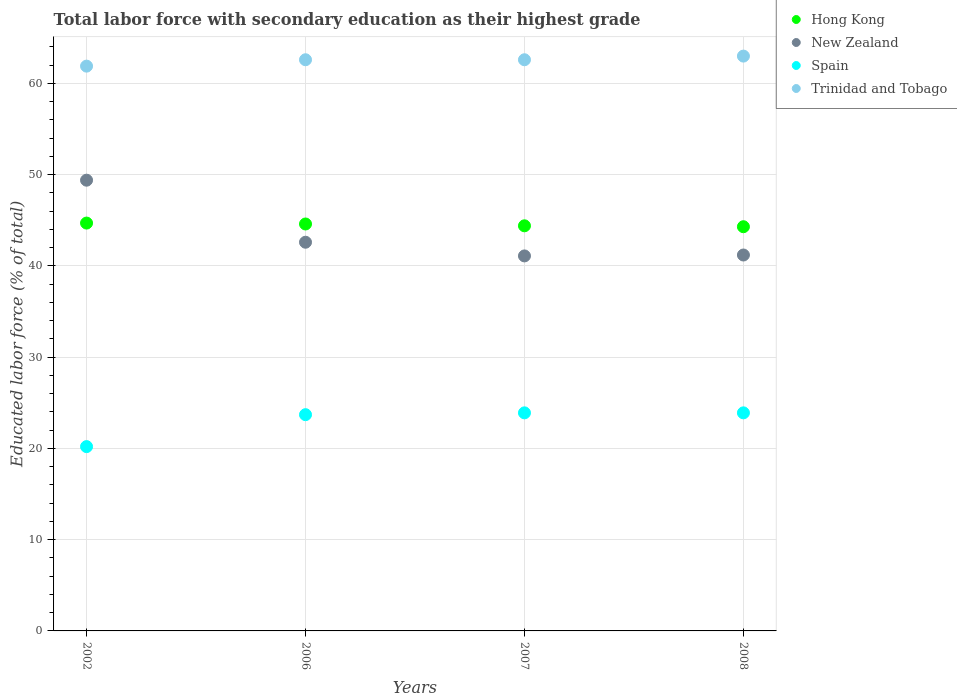How many different coloured dotlines are there?
Provide a short and direct response. 4. Is the number of dotlines equal to the number of legend labels?
Ensure brevity in your answer.  Yes. What is the percentage of total labor force with primary education in Hong Kong in 2007?
Your response must be concise. 44.4. Across all years, what is the maximum percentage of total labor force with primary education in New Zealand?
Offer a very short reply. 49.4. Across all years, what is the minimum percentage of total labor force with primary education in Spain?
Give a very brief answer. 20.2. What is the total percentage of total labor force with primary education in Hong Kong in the graph?
Keep it short and to the point. 178. What is the difference between the percentage of total labor force with primary education in Trinidad and Tobago in 2002 and that in 2008?
Give a very brief answer. -1.1. What is the difference between the percentage of total labor force with primary education in Trinidad and Tobago in 2006 and the percentage of total labor force with primary education in Hong Kong in 2002?
Your answer should be very brief. 17.9. What is the average percentage of total labor force with primary education in Trinidad and Tobago per year?
Your answer should be very brief. 62.52. In the year 2007, what is the difference between the percentage of total labor force with primary education in Hong Kong and percentage of total labor force with primary education in New Zealand?
Your response must be concise. 3.3. In how many years, is the percentage of total labor force with primary education in Hong Kong greater than 40 %?
Make the answer very short. 4. What is the ratio of the percentage of total labor force with primary education in Hong Kong in 2002 to that in 2008?
Your response must be concise. 1.01. What is the difference between the highest and the second highest percentage of total labor force with primary education in New Zealand?
Offer a very short reply. 6.8. What is the difference between the highest and the lowest percentage of total labor force with primary education in Trinidad and Tobago?
Your answer should be compact. 1.1. In how many years, is the percentage of total labor force with primary education in Trinidad and Tobago greater than the average percentage of total labor force with primary education in Trinidad and Tobago taken over all years?
Provide a succinct answer. 3. Is the sum of the percentage of total labor force with primary education in New Zealand in 2006 and 2007 greater than the maximum percentage of total labor force with primary education in Spain across all years?
Provide a short and direct response. Yes. Is it the case that in every year, the sum of the percentage of total labor force with primary education in Hong Kong and percentage of total labor force with primary education in Trinidad and Tobago  is greater than the percentage of total labor force with primary education in Spain?
Provide a short and direct response. Yes. Is the percentage of total labor force with primary education in New Zealand strictly less than the percentage of total labor force with primary education in Trinidad and Tobago over the years?
Your answer should be very brief. Yes. How many years are there in the graph?
Your answer should be compact. 4. What is the difference between two consecutive major ticks on the Y-axis?
Keep it short and to the point. 10. Are the values on the major ticks of Y-axis written in scientific E-notation?
Your answer should be compact. No. How are the legend labels stacked?
Offer a terse response. Vertical. What is the title of the graph?
Make the answer very short. Total labor force with secondary education as their highest grade. What is the label or title of the X-axis?
Your answer should be compact. Years. What is the label or title of the Y-axis?
Provide a short and direct response. Educated labor force (% of total). What is the Educated labor force (% of total) in Hong Kong in 2002?
Provide a short and direct response. 44.7. What is the Educated labor force (% of total) of New Zealand in 2002?
Ensure brevity in your answer.  49.4. What is the Educated labor force (% of total) of Spain in 2002?
Your answer should be compact. 20.2. What is the Educated labor force (% of total) in Trinidad and Tobago in 2002?
Provide a succinct answer. 61.9. What is the Educated labor force (% of total) of Hong Kong in 2006?
Offer a terse response. 44.6. What is the Educated labor force (% of total) in New Zealand in 2006?
Keep it short and to the point. 42.6. What is the Educated labor force (% of total) in Spain in 2006?
Give a very brief answer. 23.7. What is the Educated labor force (% of total) in Trinidad and Tobago in 2006?
Offer a terse response. 62.6. What is the Educated labor force (% of total) in Hong Kong in 2007?
Give a very brief answer. 44.4. What is the Educated labor force (% of total) of New Zealand in 2007?
Ensure brevity in your answer.  41.1. What is the Educated labor force (% of total) in Spain in 2007?
Provide a succinct answer. 23.9. What is the Educated labor force (% of total) in Trinidad and Tobago in 2007?
Offer a very short reply. 62.6. What is the Educated labor force (% of total) in Hong Kong in 2008?
Your answer should be very brief. 44.3. What is the Educated labor force (% of total) in New Zealand in 2008?
Provide a short and direct response. 41.2. What is the Educated labor force (% of total) of Spain in 2008?
Provide a short and direct response. 23.9. Across all years, what is the maximum Educated labor force (% of total) in Hong Kong?
Your answer should be very brief. 44.7. Across all years, what is the maximum Educated labor force (% of total) of New Zealand?
Provide a short and direct response. 49.4. Across all years, what is the maximum Educated labor force (% of total) in Spain?
Keep it short and to the point. 23.9. Across all years, what is the maximum Educated labor force (% of total) of Trinidad and Tobago?
Keep it short and to the point. 63. Across all years, what is the minimum Educated labor force (% of total) in Hong Kong?
Offer a very short reply. 44.3. Across all years, what is the minimum Educated labor force (% of total) in New Zealand?
Provide a succinct answer. 41.1. Across all years, what is the minimum Educated labor force (% of total) in Spain?
Your response must be concise. 20.2. Across all years, what is the minimum Educated labor force (% of total) of Trinidad and Tobago?
Offer a very short reply. 61.9. What is the total Educated labor force (% of total) of Hong Kong in the graph?
Make the answer very short. 178. What is the total Educated labor force (% of total) in New Zealand in the graph?
Give a very brief answer. 174.3. What is the total Educated labor force (% of total) of Spain in the graph?
Ensure brevity in your answer.  91.7. What is the total Educated labor force (% of total) in Trinidad and Tobago in the graph?
Make the answer very short. 250.1. What is the difference between the Educated labor force (% of total) in Hong Kong in 2002 and that in 2006?
Ensure brevity in your answer.  0.1. What is the difference between the Educated labor force (% of total) of New Zealand in 2002 and that in 2006?
Keep it short and to the point. 6.8. What is the difference between the Educated labor force (% of total) of Trinidad and Tobago in 2002 and that in 2006?
Your response must be concise. -0.7. What is the difference between the Educated labor force (% of total) of Trinidad and Tobago in 2002 and that in 2008?
Make the answer very short. -1.1. What is the difference between the Educated labor force (% of total) of New Zealand in 2006 and that in 2007?
Your response must be concise. 1.5. What is the difference between the Educated labor force (% of total) of Spain in 2006 and that in 2007?
Give a very brief answer. -0.2. What is the difference between the Educated labor force (% of total) in Spain in 2006 and that in 2008?
Provide a short and direct response. -0.2. What is the difference between the Educated labor force (% of total) of Hong Kong in 2007 and that in 2008?
Ensure brevity in your answer.  0.1. What is the difference between the Educated labor force (% of total) of Spain in 2007 and that in 2008?
Offer a very short reply. 0. What is the difference between the Educated labor force (% of total) in Hong Kong in 2002 and the Educated labor force (% of total) in New Zealand in 2006?
Offer a very short reply. 2.1. What is the difference between the Educated labor force (% of total) of Hong Kong in 2002 and the Educated labor force (% of total) of Spain in 2006?
Offer a terse response. 21. What is the difference between the Educated labor force (% of total) in Hong Kong in 2002 and the Educated labor force (% of total) in Trinidad and Tobago in 2006?
Keep it short and to the point. -17.9. What is the difference between the Educated labor force (% of total) in New Zealand in 2002 and the Educated labor force (% of total) in Spain in 2006?
Your answer should be compact. 25.7. What is the difference between the Educated labor force (% of total) in New Zealand in 2002 and the Educated labor force (% of total) in Trinidad and Tobago in 2006?
Make the answer very short. -13.2. What is the difference between the Educated labor force (% of total) of Spain in 2002 and the Educated labor force (% of total) of Trinidad and Tobago in 2006?
Your answer should be very brief. -42.4. What is the difference between the Educated labor force (% of total) in Hong Kong in 2002 and the Educated labor force (% of total) in New Zealand in 2007?
Offer a very short reply. 3.6. What is the difference between the Educated labor force (% of total) in Hong Kong in 2002 and the Educated labor force (% of total) in Spain in 2007?
Ensure brevity in your answer.  20.8. What is the difference between the Educated labor force (% of total) in Hong Kong in 2002 and the Educated labor force (% of total) in Trinidad and Tobago in 2007?
Your answer should be compact. -17.9. What is the difference between the Educated labor force (% of total) of Spain in 2002 and the Educated labor force (% of total) of Trinidad and Tobago in 2007?
Keep it short and to the point. -42.4. What is the difference between the Educated labor force (% of total) in Hong Kong in 2002 and the Educated labor force (% of total) in New Zealand in 2008?
Ensure brevity in your answer.  3.5. What is the difference between the Educated labor force (% of total) of Hong Kong in 2002 and the Educated labor force (% of total) of Spain in 2008?
Give a very brief answer. 20.8. What is the difference between the Educated labor force (% of total) of Hong Kong in 2002 and the Educated labor force (% of total) of Trinidad and Tobago in 2008?
Your response must be concise. -18.3. What is the difference between the Educated labor force (% of total) in New Zealand in 2002 and the Educated labor force (% of total) in Spain in 2008?
Your response must be concise. 25.5. What is the difference between the Educated labor force (% of total) in Spain in 2002 and the Educated labor force (% of total) in Trinidad and Tobago in 2008?
Provide a succinct answer. -42.8. What is the difference between the Educated labor force (% of total) of Hong Kong in 2006 and the Educated labor force (% of total) of New Zealand in 2007?
Offer a very short reply. 3.5. What is the difference between the Educated labor force (% of total) in Hong Kong in 2006 and the Educated labor force (% of total) in Spain in 2007?
Give a very brief answer. 20.7. What is the difference between the Educated labor force (% of total) in Hong Kong in 2006 and the Educated labor force (% of total) in Trinidad and Tobago in 2007?
Provide a succinct answer. -18. What is the difference between the Educated labor force (% of total) in New Zealand in 2006 and the Educated labor force (% of total) in Trinidad and Tobago in 2007?
Your response must be concise. -20. What is the difference between the Educated labor force (% of total) in Spain in 2006 and the Educated labor force (% of total) in Trinidad and Tobago in 2007?
Provide a short and direct response. -38.9. What is the difference between the Educated labor force (% of total) of Hong Kong in 2006 and the Educated labor force (% of total) of New Zealand in 2008?
Offer a very short reply. 3.4. What is the difference between the Educated labor force (% of total) in Hong Kong in 2006 and the Educated labor force (% of total) in Spain in 2008?
Offer a very short reply. 20.7. What is the difference between the Educated labor force (% of total) in Hong Kong in 2006 and the Educated labor force (% of total) in Trinidad and Tobago in 2008?
Your answer should be compact. -18.4. What is the difference between the Educated labor force (% of total) in New Zealand in 2006 and the Educated labor force (% of total) in Trinidad and Tobago in 2008?
Ensure brevity in your answer.  -20.4. What is the difference between the Educated labor force (% of total) in Spain in 2006 and the Educated labor force (% of total) in Trinidad and Tobago in 2008?
Ensure brevity in your answer.  -39.3. What is the difference between the Educated labor force (% of total) in Hong Kong in 2007 and the Educated labor force (% of total) in New Zealand in 2008?
Your answer should be compact. 3.2. What is the difference between the Educated labor force (% of total) in Hong Kong in 2007 and the Educated labor force (% of total) in Spain in 2008?
Ensure brevity in your answer.  20.5. What is the difference between the Educated labor force (% of total) of Hong Kong in 2007 and the Educated labor force (% of total) of Trinidad and Tobago in 2008?
Ensure brevity in your answer.  -18.6. What is the difference between the Educated labor force (% of total) of New Zealand in 2007 and the Educated labor force (% of total) of Spain in 2008?
Provide a short and direct response. 17.2. What is the difference between the Educated labor force (% of total) of New Zealand in 2007 and the Educated labor force (% of total) of Trinidad and Tobago in 2008?
Give a very brief answer. -21.9. What is the difference between the Educated labor force (% of total) in Spain in 2007 and the Educated labor force (% of total) in Trinidad and Tobago in 2008?
Offer a terse response. -39.1. What is the average Educated labor force (% of total) of Hong Kong per year?
Make the answer very short. 44.5. What is the average Educated labor force (% of total) of New Zealand per year?
Offer a very short reply. 43.58. What is the average Educated labor force (% of total) in Spain per year?
Make the answer very short. 22.93. What is the average Educated labor force (% of total) in Trinidad and Tobago per year?
Provide a succinct answer. 62.52. In the year 2002, what is the difference between the Educated labor force (% of total) of Hong Kong and Educated labor force (% of total) of Spain?
Provide a short and direct response. 24.5. In the year 2002, what is the difference between the Educated labor force (% of total) in Hong Kong and Educated labor force (% of total) in Trinidad and Tobago?
Your response must be concise. -17.2. In the year 2002, what is the difference between the Educated labor force (% of total) of New Zealand and Educated labor force (% of total) of Spain?
Offer a very short reply. 29.2. In the year 2002, what is the difference between the Educated labor force (% of total) in New Zealand and Educated labor force (% of total) in Trinidad and Tobago?
Your answer should be compact. -12.5. In the year 2002, what is the difference between the Educated labor force (% of total) in Spain and Educated labor force (% of total) in Trinidad and Tobago?
Ensure brevity in your answer.  -41.7. In the year 2006, what is the difference between the Educated labor force (% of total) in Hong Kong and Educated labor force (% of total) in Spain?
Make the answer very short. 20.9. In the year 2006, what is the difference between the Educated labor force (% of total) in New Zealand and Educated labor force (% of total) in Spain?
Your answer should be very brief. 18.9. In the year 2006, what is the difference between the Educated labor force (% of total) of Spain and Educated labor force (% of total) of Trinidad and Tobago?
Your answer should be compact. -38.9. In the year 2007, what is the difference between the Educated labor force (% of total) of Hong Kong and Educated labor force (% of total) of Trinidad and Tobago?
Give a very brief answer. -18.2. In the year 2007, what is the difference between the Educated labor force (% of total) of New Zealand and Educated labor force (% of total) of Trinidad and Tobago?
Ensure brevity in your answer.  -21.5. In the year 2007, what is the difference between the Educated labor force (% of total) of Spain and Educated labor force (% of total) of Trinidad and Tobago?
Give a very brief answer. -38.7. In the year 2008, what is the difference between the Educated labor force (% of total) of Hong Kong and Educated labor force (% of total) of New Zealand?
Offer a terse response. 3.1. In the year 2008, what is the difference between the Educated labor force (% of total) of Hong Kong and Educated labor force (% of total) of Spain?
Ensure brevity in your answer.  20.4. In the year 2008, what is the difference between the Educated labor force (% of total) in Hong Kong and Educated labor force (% of total) in Trinidad and Tobago?
Ensure brevity in your answer.  -18.7. In the year 2008, what is the difference between the Educated labor force (% of total) in New Zealand and Educated labor force (% of total) in Trinidad and Tobago?
Keep it short and to the point. -21.8. In the year 2008, what is the difference between the Educated labor force (% of total) of Spain and Educated labor force (% of total) of Trinidad and Tobago?
Provide a short and direct response. -39.1. What is the ratio of the Educated labor force (% of total) of Hong Kong in 2002 to that in 2006?
Provide a short and direct response. 1. What is the ratio of the Educated labor force (% of total) of New Zealand in 2002 to that in 2006?
Provide a short and direct response. 1.16. What is the ratio of the Educated labor force (% of total) in Spain in 2002 to that in 2006?
Ensure brevity in your answer.  0.85. What is the ratio of the Educated labor force (% of total) in Trinidad and Tobago in 2002 to that in 2006?
Provide a succinct answer. 0.99. What is the ratio of the Educated labor force (% of total) in Hong Kong in 2002 to that in 2007?
Keep it short and to the point. 1.01. What is the ratio of the Educated labor force (% of total) in New Zealand in 2002 to that in 2007?
Offer a terse response. 1.2. What is the ratio of the Educated labor force (% of total) of Spain in 2002 to that in 2007?
Offer a terse response. 0.85. What is the ratio of the Educated labor force (% of total) of Trinidad and Tobago in 2002 to that in 2007?
Provide a short and direct response. 0.99. What is the ratio of the Educated labor force (% of total) in Hong Kong in 2002 to that in 2008?
Give a very brief answer. 1.01. What is the ratio of the Educated labor force (% of total) of New Zealand in 2002 to that in 2008?
Keep it short and to the point. 1.2. What is the ratio of the Educated labor force (% of total) in Spain in 2002 to that in 2008?
Make the answer very short. 0.85. What is the ratio of the Educated labor force (% of total) of Trinidad and Tobago in 2002 to that in 2008?
Your answer should be compact. 0.98. What is the ratio of the Educated labor force (% of total) of New Zealand in 2006 to that in 2007?
Your answer should be compact. 1.04. What is the ratio of the Educated labor force (% of total) in Hong Kong in 2006 to that in 2008?
Give a very brief answer. 1.01. What is the ratio of the Educated labor force (% of total) in New Zealand in 2006 to that in 2008?
Provide a short and direct response. 1.03. What is the ratio of the Educated labor force (% of total) in Spain in 2006 to that in 2008?
Offer a very short reply. 0.99. What is the ratio of the Educated labor force (% of total) of Trinidad and Tobago in 2006 to that in 2008?
Provide a short and direct response. 0.99. What is the ratio of the Educated labor force (% of total) in New Zealand in 2007 to that in 2008?
Provide a short and direct response. 1. What is the ratio of the Educated labor force (% of total) of Trinidad and Tobago in 2007 to that in 2008?
Give a very brief answer. 0.99. What is the difference between the highest and the second highest Educated labor force (% of total) of Trinidad and Tobago?
Your answer should be very brief. 0.4. What is the difference between the highest and the lowest Educated labor force (% of total) in Hong Kong?
Offer a terse response. 0.4. What is the difference between the highest and the lowest Educated labor force (% of total) of New Zealand?
Offer a very short reply. 8.3. 